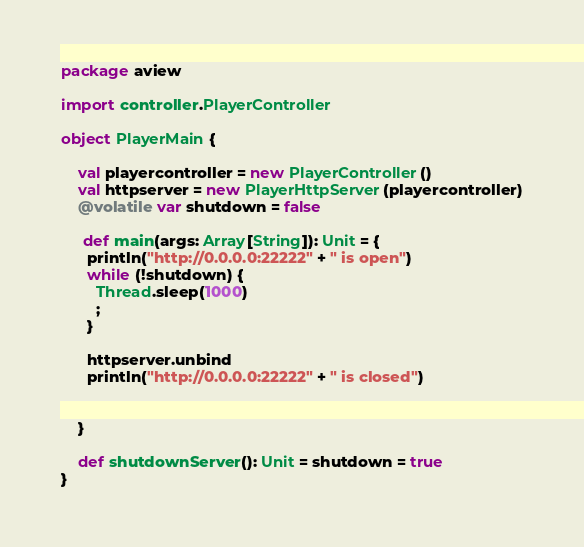Convert code to text. <code><loc_0><loc_0><loc_500><loc_500><_Scala_>package aview

import controller.PlayerController

object PlayerMain {

    val playercontroller = new PlayerController()
    val httpserver = new PlayerHttpServer(playercontroller)
    @volatile var shutdown = false

     def main(args: Array[String]): Unit = {
      println("http://0.0.0.0:22222" + " is open")
      while (!shutdown) {
        Thread.sleep(1000)
        ;
      }

      httpserver.unbind
      println("http://0.0.0.0:22222" + " is closed")


    }

    def shutdownServer(): Unit = shutdown = true
}
</code> 